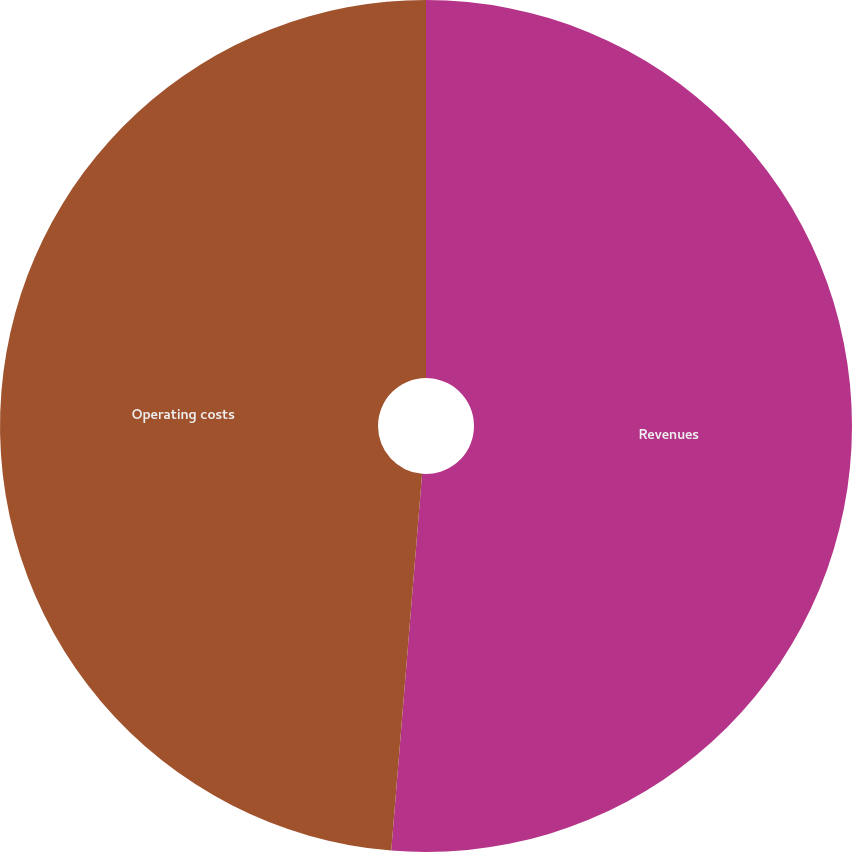<chart> <loc_0><loc_0><loc_500><loc_500><pie_chart><fcel>Revenues<fcel>Operating costs<nl><fcel>51.3%<fcel>48.7%<nl></chart> 